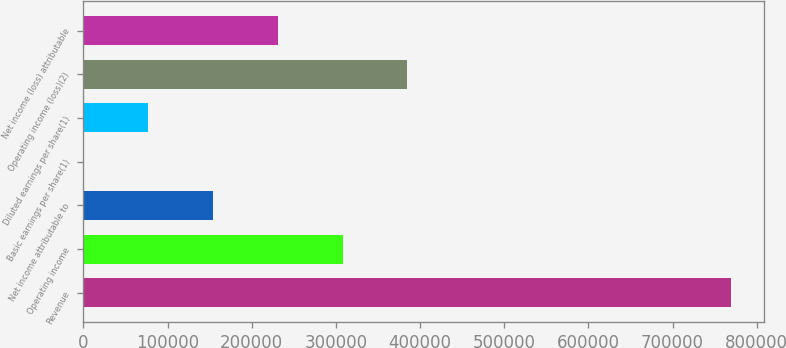Convert chart to OTSL. <chart><loc_0><loc_0><loc_500><loc_500><bar_chart><fcel>Revenue<fcel>Operating income<fcel>Net income attributable to<fcel>Basic earnings per share(1)<fcel>Diluted earnings per share(1)<fcel>Operating income (loss)(2)<fcel>Net income (loss) attributable<nl><fcel>769768<fcel>307907<fcel>153954<fcel>0.14<fcel>76976.9<fcel>384884<fcel>230931<nl></chart> 